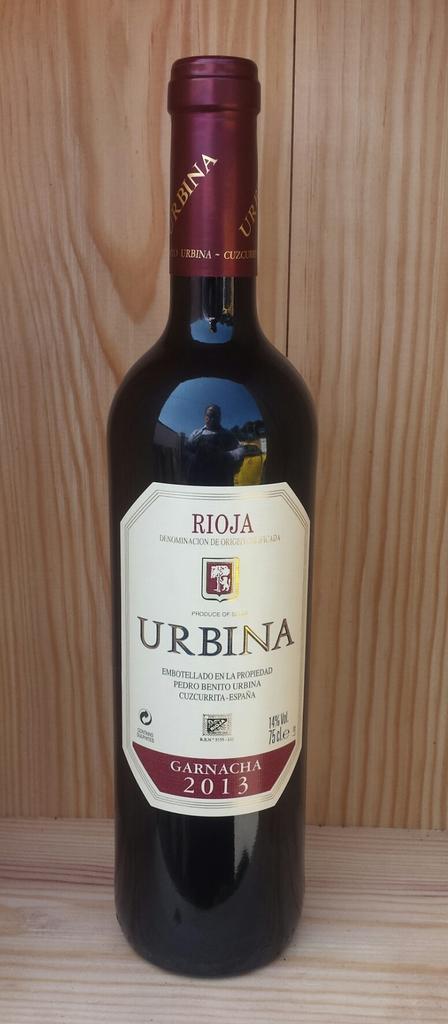How would you summarize this image in a sentence or two? In this image I can see the bottle on the wooden surface and the bottle is in black and maroon color. In the background I can see the wooden wall and the wall is in brown color. 